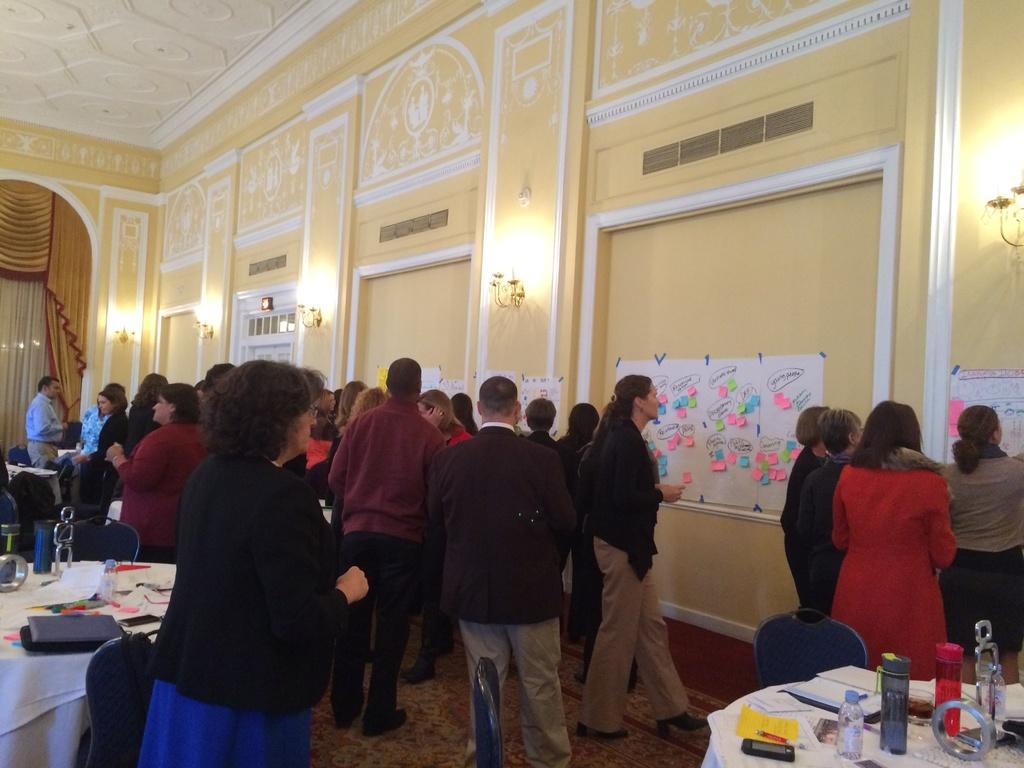How many people are in the image? There are many people in the image. What are the people doing in the image? The people are looking at posters and charts on the wall. Can you describe the location of the image? The location appears to be an art museum. What type of slope can be seen in the image? There is no slope present in the image; it is set in an art museum with people looking at posters and charts on the wall. 